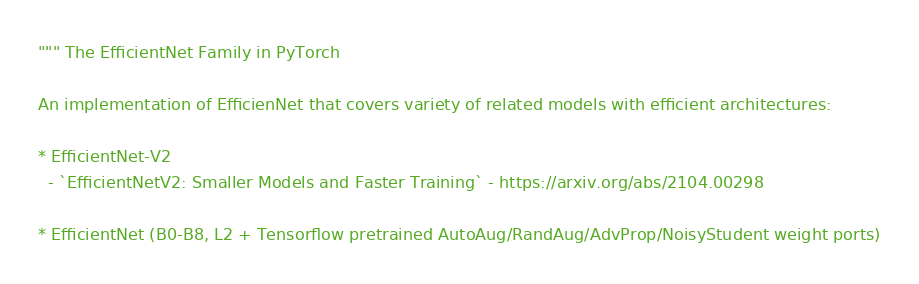<code> <loc_0><loc_0><loc_500><loc_500><_Python_>""" The EfficientNet Family in PyTorch

An implementation of EfficienNet that covers variety of related models with efficient architectures:

* EfficientNet-V2
  - `EfficientNetV2: Smaller Models and Faster Training` - https://arxiv.org/abs/2104.00298

* EfficientNet (B0-B8, L2 + Tensorflow pretrained AutoAug/RandAug/AdvProp/NoisyStudent weight ports)</code> 